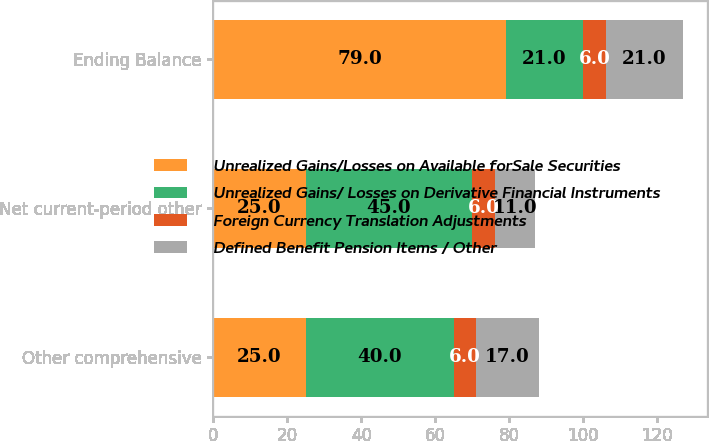Convert chart to OTSL. <chart><loc_0><loc_0><loc_500><loc_500><stacked_bar_chart><ecel><fcel>Other comprehensive<fcel>Net current-period other<fcel>Ending Balance<nl><fcel>Unrealized Gains/Losses on Available forSale Securities<fcel>25<fcel>25<fcel>79<nl><fcel>Unrealized Gains/ Losses on Derivative Financial Instruments<fcel>40<fcel>45<fcel>21<nl><fcel>Foreign Currency Translation Adjustments<fcel>6<fcel>6<fcel>6<nl><fcel>Defined Benefit Pension Items / Other<fcel>17<fcel>11<fcel>21<nl></chart> 